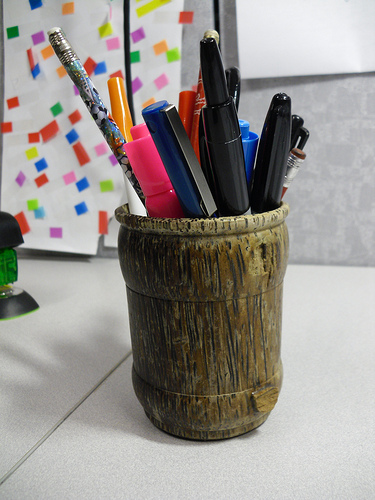<image>
Can you confirm if the pen is on the table? Yes. Looking at the image, I can see the pen is positioned on top of the table, with the table providing support. 